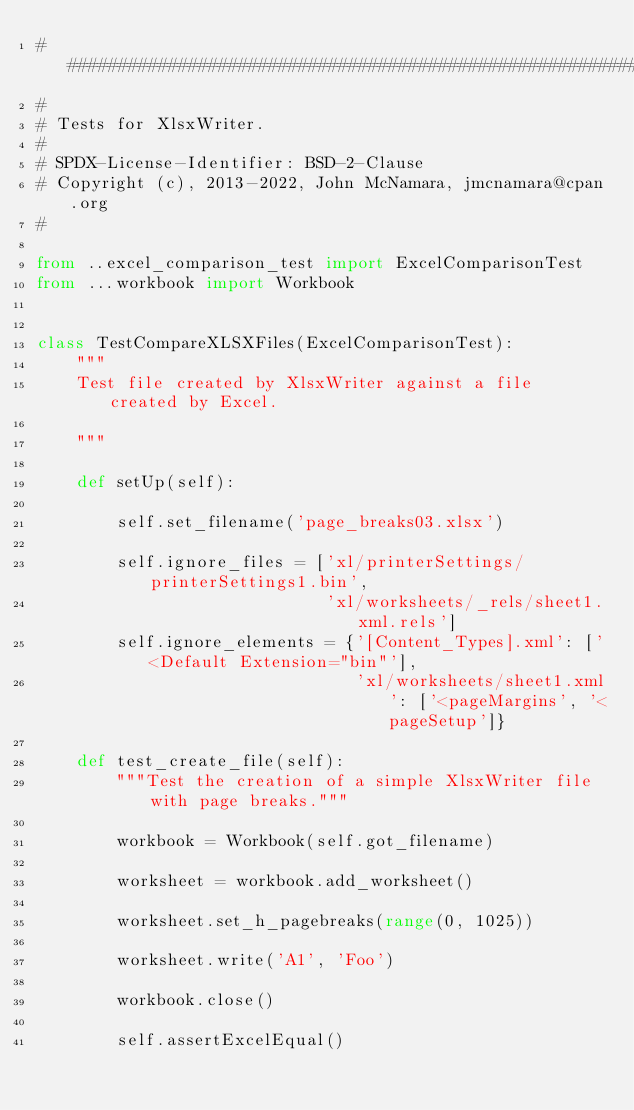<code> <loc_0><loc_0><loc_500><loc_500><_Python_>###############################################################################
#
# Tests for XlsxWriter.
#
# SPDX-License-Identifier: BSD-2-Clause
# Copyright (c), 2013-2022, John McNamara, jmcnamara@cpan.org
#

from ..excel_comparison_test import ExcelComparisonTest
from ...workbook import Workbook


class TestCompareXLSXFiles(ExcelComparisonTest):
    """
    Test file created by XlsxWriter against a file created by Excel.

    """

    def setUp(self):

        self.set_filename('page_breaks03.xlsx')

        self.ignore_files = ['xl/printerSettings/printerSettings1.bin',
                             'xl/worksheets/_rels/sheet1.xml.rels']
        self.ignore_elements = {'[Content_Types].xml': ['<Default Extension="bin"'],
                                'xl/worksheets/sheet1.xml': ['<pageMargins', '<pageSetup']}

    def test_create_file(self):
        """Test the creation of a simple XlsxWriter file with page breaks."""

        workbook = Workbook(self.got_filename)

        worksheet = workbook.add_worksheet()

        worksheet.set_h_pagebreaks(range(0, 1025))

        worksheet.write('A1', 'Foo')

        workbook.close()

        self.assertExcelEqual()
</code> 